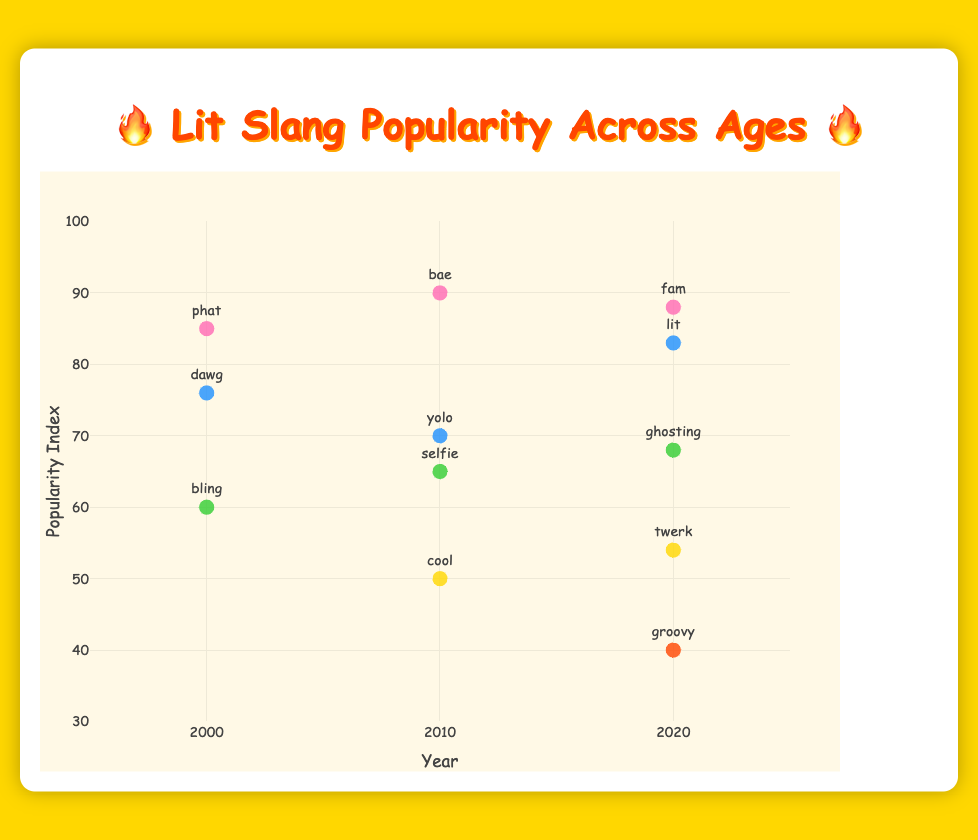Which age group had the highest popularity index in 2020? Observing the points in 2020 on the scatter plot, the 10-19 age group has the highest popularity index at 88.
Answer: 10-19 What is the title of the figure? The title is prominently displayed at the top of the chart.
Answer: Lit Slang Popularity Across Ages Which slang term was most popular in the 10-19 age group in 2010? Looking at the scatter plot for the 10-19 age group in 2010, the highest popularity index is for "bae" at 90.
Answer: bae How does the popularity of the slang term in the 20-29 age group change from 2000 to 2020? Comparing the points for the 20-29 age group across 2000 to 2020, the popularity index increases from 76 ("dawg") in 2000 to 83 ("lit") in 2020.
Answer: Increases Which age group has the lowest popularity index in 2020? Observing the scatter plot for the year 2020, the 50-59 age group has the lowest popularity index at 40.
Answer: 50-59 Compare the popularity index of the term "selfie" in 2010 to the term "ghosting" in 2020. In the scatter plot, "selfie" in 2010 has a popularity index of 65, while "ghosting" in 2020 has a popularity index of 68.
Answer: Ghosting is higher What is the average popularity index of all slang terms in 2010? Sum the popularity indices for 2010: 90 (bae) + 70 (yolo) + 65 (selfie) + 50 (cool) = 275. There are 4 terms, so divide 275 by 4.
Answer: 68.75 How does the popularity of "bling" in 2000 compare to "twerk" in 2020? "Bling" in 2000 has a popularity index of 60, while "twerk" in 2020 has a popularity index of 54.
Answer: Bling is higher What is the trend for the 10-19 age group's slang popularity from 2000 to 2020? Observing the trend in the scatter plot for the 10-19 age group, the popularity index rose from 85 ("phat") in 2000 to 90 ("bae") in 2010 and then slightly decreased to 88 ("fam") in 2020.
Answer: Slight increase then slight decrease 